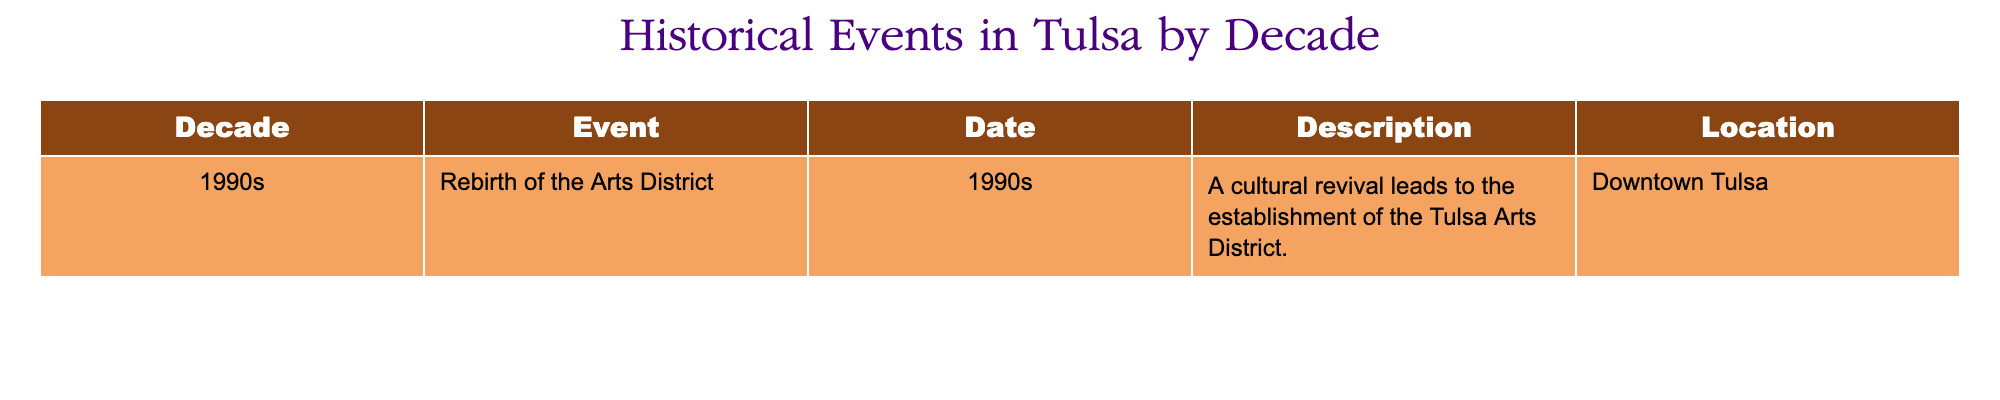What decade did the event "Rebirth of the Arts District" occur? The table lists the event "Rebirth of the Arts District" in the 1990s. Therefore, the decade is 1990s.
Answer: 1990s What location is associated with the "Rebirth of the Arts District"? According to the table, the event "Rebirth of the Arts District" is located in "Downtown Tulsa."
Answer: Downtown Tulsa Does the table include events from the 1980s? The provided data only shows events from the 1990s, with no entries listed for the 1980s. Thus, the answer is no.
Answer: No What is the description of the event that occurred in the 1990s? In the table, the description for the "Rebirth of the Arts District" event states it was a cultural revival leading to the establishment of the Tulsa Arts District.
Answer: A cultural revival leads to the establishment of the Tulsa Arts District How many events are listed in the table for the decade of the 1990s? There is only one event listed in the table for the 1990s, which is the "Rebirth of the Arts District." Therefore, the count is one.
Answer: 1 Was the "Rebirth of the Arts District" a significant cultural event? The description indicates that it was a cultural revival and led to the establishment of an arts district, suggesting its significance in promoting culture. Therefore, the answer is yes.
Answer: Yes Can we conclude that all events in the table occurred in the 1990s? Since the table only contains one event, and it occurred in the 1990s, it follows that all events listed (which is just one) did occur in that decade.
Answer: Yes What type of impact did the "Rebirth of the Arts District" have on the Tulsa area? The description indicates it led to a cultural revival and the establishment of an arts district, suggesting a positive cultural impact on the area. This requires a combination of interpreting the description and considering its implications.
Answer: Positive cultural impact 